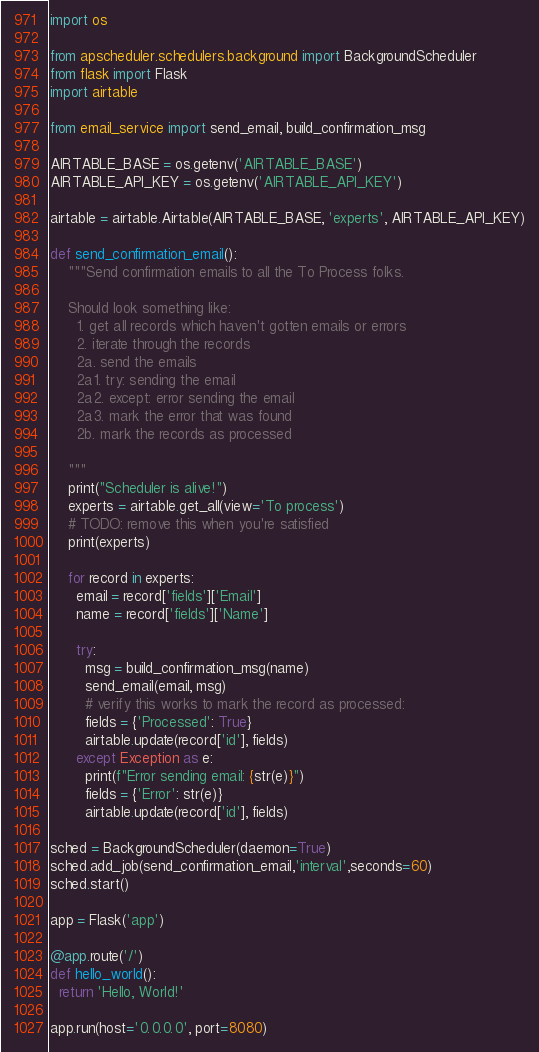<code> <loc_0><loc_0><loc_500><loc_500><_Python_>import os

from apscheduler.schedulers.background import BackgroundScheduler
from flask import Flask
import airtable

from email_service import send_email, build_confirmation_msg

AIRTABLE_BASE = os.getenv('AIRTABLE_BASE')
AIRTABLE_API_KEY = os.getenv('AIRTABLE_API_KEY')

airtable = airtable.Airtable(AIRTABLE_BASE, 'experts', AIRTABLE_API_KEY)

def send_confirmation_email():
    """Send confirmation emails to all the To Process folks.

    Should look something like:
      1. get all records which haven't gotten emails or errors
      2. iterate through the records
      2a. send the emails
      2a1. try: sending the email
      2a2. except: error sending the email
      2a3. mark the error that was found
      2b. mark the records as processed
    
    """
    print("Scheduler is alive!")
    experts = airtable.get_all(view='To process')
    # TODO: remove this when you're satisfied
    print(experts)

    for record in experts:
      email = record['fields']['Email']
      name = record['fields']['Name']

      try:
        msg = build_confirmation_msg(name)
        send_email(email, msg)
        # verify this works to mark the record as processed:
        fields = {'Processed': True}
        airtable.update(record['id'], fields)
      except Exception as e:
        print(f"Error sending email: {str(e)}")
        fields = {'Error': str(e)}
        airtable.update(record['id'], fields)

sched = BackgroundScheduler(daemon=True)
sched.add_job(send_confirmation_email,'interval',seconds=60)
sched.start()

app = Flask('app')

@app.route('/')
def hello_world():
  return 'Hello, World!'

app.run(host='0.0.0.0', port=8080)
</code> 